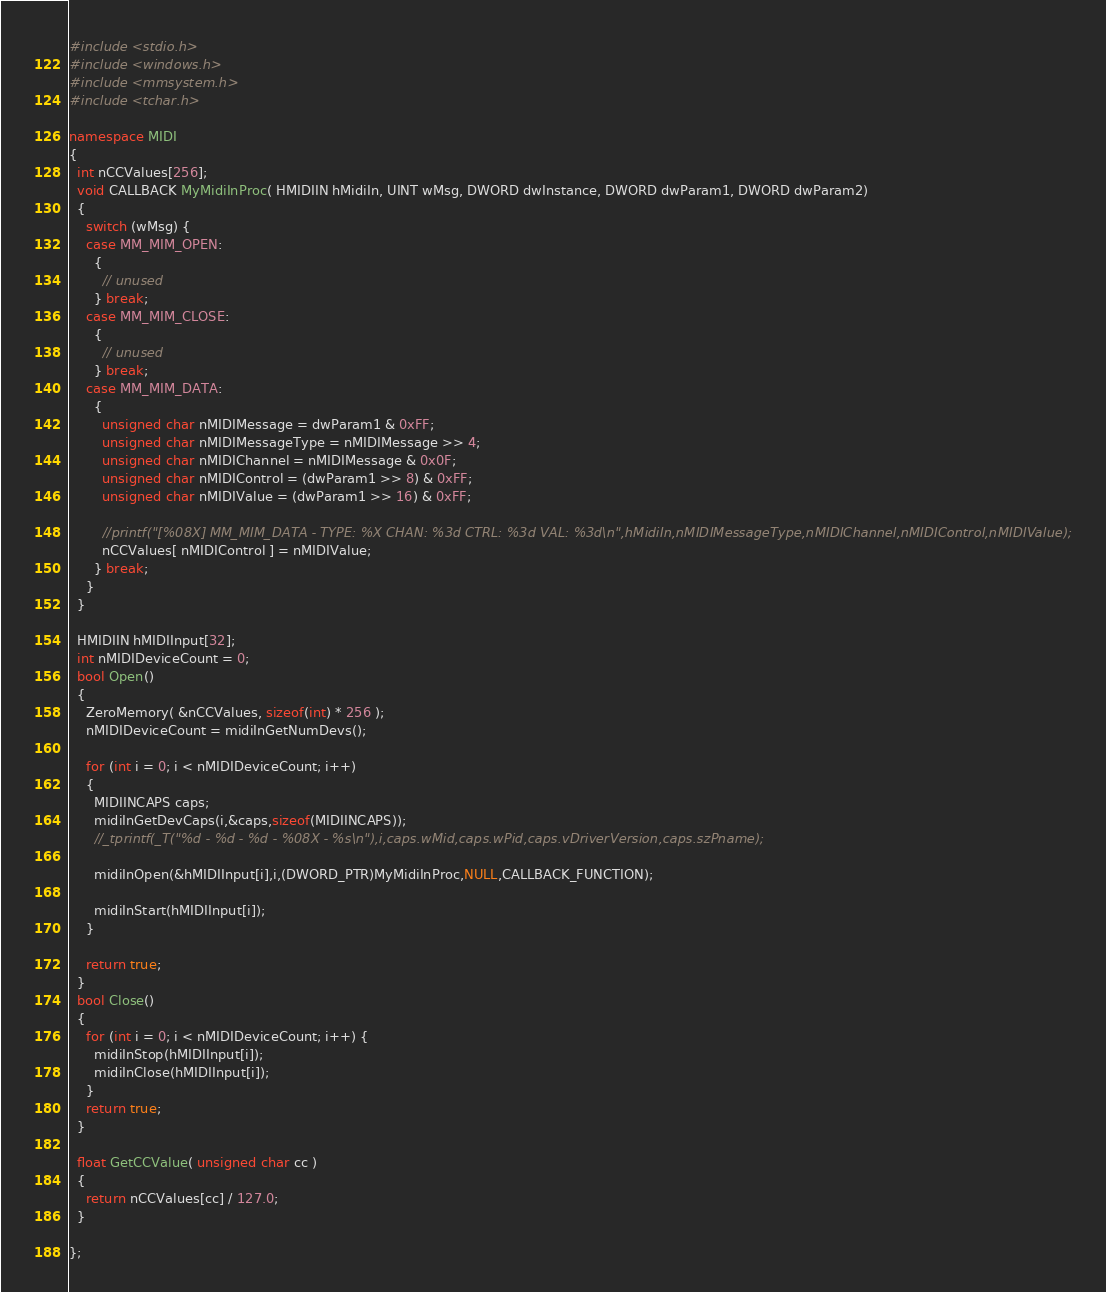<code> <loc_0><loc_0><loc_500><loc_500><_C++_>#include <stdio.h>
#include <windows.h>
#include <mmsystem.h>
#include <tchar.h>

namespace MIDI
{
  int nCCValues[256];
  void CALLBACK MyMidiInProc( HMIDIIN hMidiIn, UINT wMsg, DWORD dwInstance, DWORD dwParam1, DWORD dwParam2) 
  {
    switch (wMsg) {
    case MM_MIM_OPEN:
      {
        // unused
      } break;
    case MM_MIM_CLOSE:
      {
        // unused
      } break;
    case MM_MIM_DATA:
      {
        unsigned char nMIDIMessage = dwParam1 & 0xFF;
        unsigned char nMIDIMessageType = nMIDIMessage >> 4;
        unsigned char nMIDIChannel = nMIDIMessage & 0x0F;
        unsigned char nMIDIControl = (dwParam1 >> 8) & 0xFF;
        unsigned char nMIDIValue = (dwParam1 >> 16) & 0xFF;

        //printf("[%08X] MM_MIM_DATA - TYPE: %X CHAN: %3d CTRL: %3d VAL: %3d\n",hMidiIn,nMIDIMessageType,nMIDIChannel,nMIDIControl,nMIDIValue);
        nCCValues[ nMIDIControl ] = nMIDIValue;
      } break;
    }
  }

  HMIDIIN hMIDIInput[32];
  int nMIDIDeviceCount = 0;
  bool Open()
  {
    ZeroMemory( &nCCValues, sizeof(int) * 256 );
    nMIDIDeviceCount = midiInGetNumDevs();

    for (int i = 0; i < nMIDIDeviceCount; i++) 
    {
      MIDIINCAPS caps;
      midiInGetDevCaps(i,&caps,sizeof(MIDIINCAPS));
      //_tprintf(_T("%d - %d - %d - %08X - %s\n"),i,caps.wMid,caps.wPid,caps.vDriverVersion,caps.szPname);

      midiInOpen(&hMIDIInput[i],i,(DWORD_PTR)MyMidiInProc,NULL,CALLBACK_FUNCTION);

      midiInStart(hMIDIInput[i]);
    }

    return true;
  }
  bool Close()
  {
    for (int i = 0; i < nMIDIDeviceCount; i++) {
      midiInStop(hMIDIInput[i]);
      midiInClose(hMIDIInput[i]);
    }
    return true;
  }

  float GetCCValue( unsigned char cc )
  {
    return nCCValues[cc] / 127.0;
  }

};</code> 